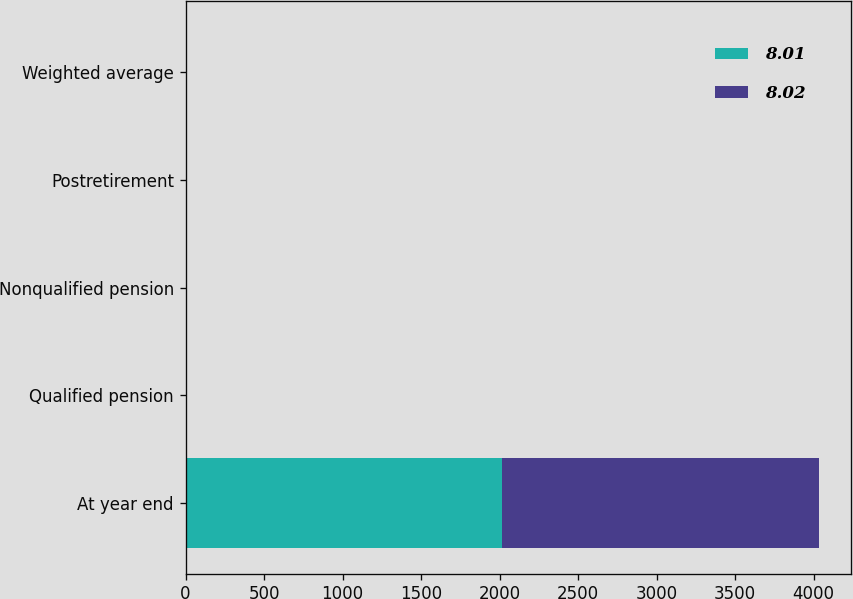Convert chart. <chart><loc_0><loc_0><loc_500><loc_500><stacked_bar_chart><ecel><fcel>At year end<fcel>Qualified pension<fcel>Nonqualified pension<fcel>Postretirement<fcel>Weighted average<nl><fcel>8.01<fcel>2017<fcel>3.6<fcel>3.6<fcel>3.5<fcel>4.17<nl><fcel>8.02<fcel>2016<fcel>4.1<fcel>4<fcel>3.9<fcel>4.4<nl></chart> 